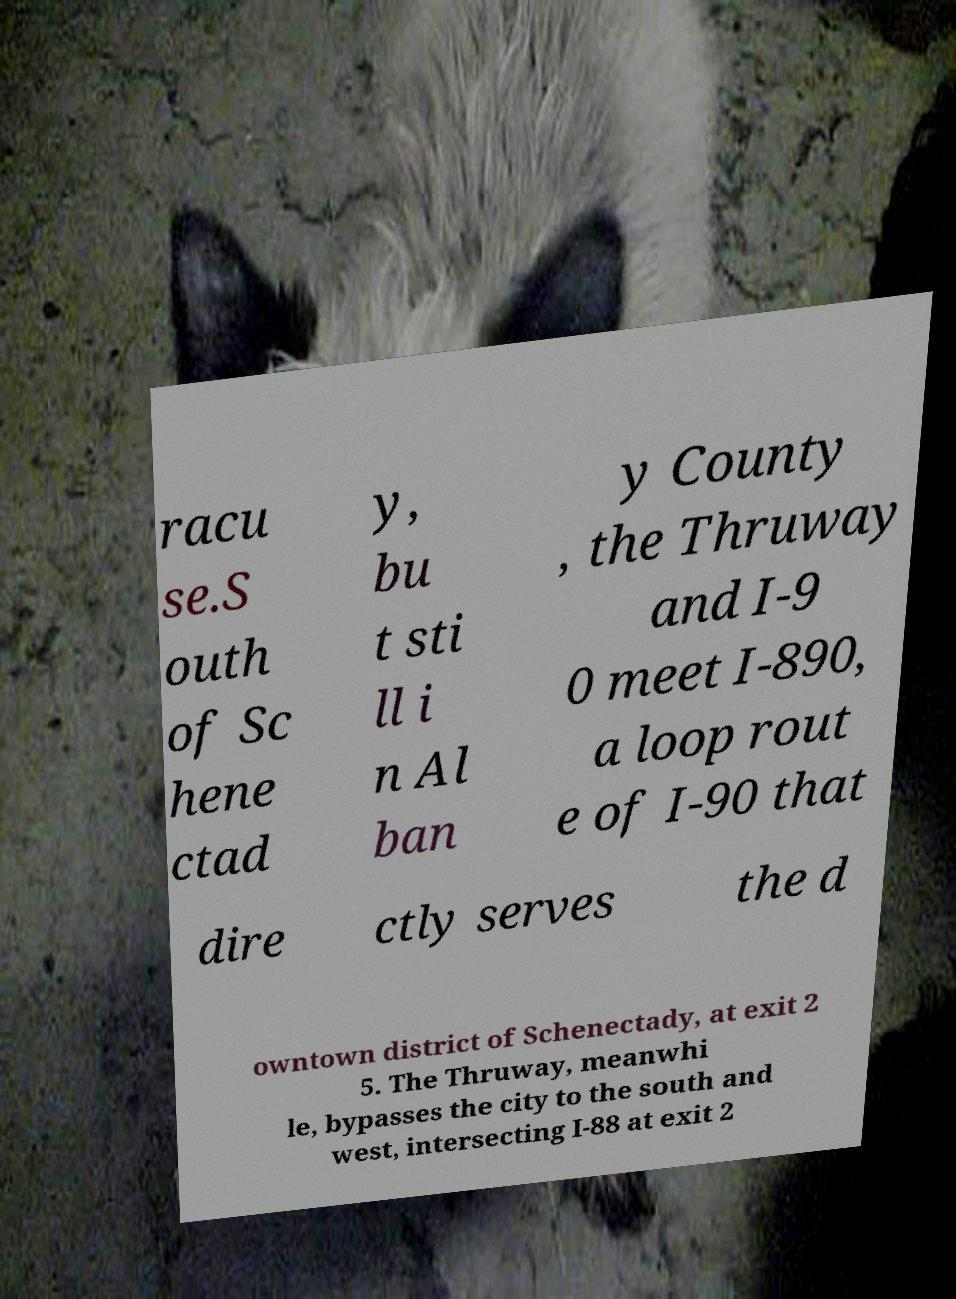Could you assist in decoding the text presented in this image and type it out clearly? racu se.S outh of Sc hene ctad y, bu t sti ll i n Al ban y County , the Thruway and I-9 0 meet I-890, a loop rout e of I-90 that dire ctly serves the d owntown district of Schenectady, at exit 2 5. The Thruway, meanwhi le, bypasses the city to the south and west, intersecting I-88 at exit 2 